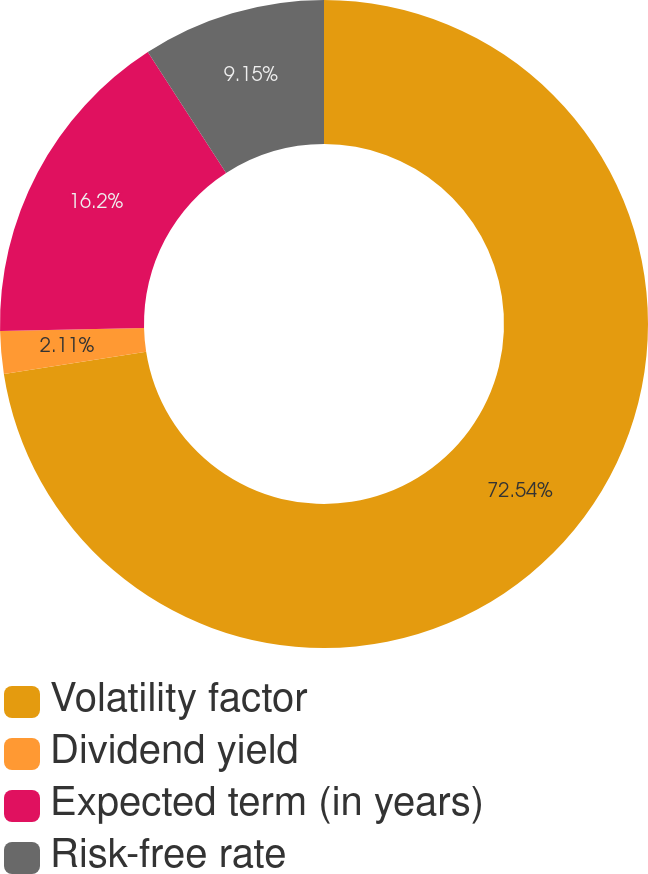Convert chart to OTSL. <chart><loc_0><loc_0><loc_500><loc_500><pie_chart><fcel>Volatility factor<fcel>Dividend yield<fcel>Expected term (in years)<fcel>Risk-free rate<nl><fcel>72.54%<fcel>2.11%<fcel>16.2%<fcel>9.15%<nl></chart> 